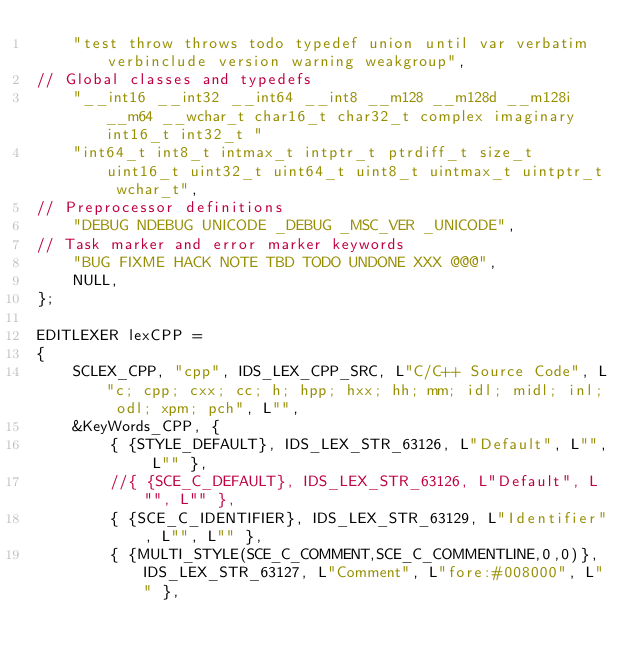<code> <loc_0><loc_0><loc_500><loc_500><_C_>    "test throw throws todo typedef union until var verbatim verbinclude version warning weakgroup",
// Global classes and typedefs
    "__int16 __int32 __int64 __int8 __m128 __m128d __m128i __m64 __wchar_t char16_t char32_t complex imaginary int16_t int32_t "
    "int64_t int8_t intmax_t intptr_t ptrdiff_t size_t uint16_t uint32_t uint64_t uint8_t uintmax_t uintptr_t wchar_t",
// Preprocessor definitions
    "DEBUG NDEBUG UNICODE _DEBUG _MSC_VER _UNICODE",
// Task marker and error marker keywords
    "BUG FIXME HACK NOTE TBD TODO UNDONE XXX @@@",
    NULL,
};

EDITLEXER lexCPP =
{
    SCLEX_CPP, "cpp", IDS_LEX_CPP_SRC, L"C/C++ Source Code", L"c; cpp; cxx; cc; h; hpp; hxx; hh; mm; idl; midl; inl; odl; xpm; pch", L"",
    &KeyWords_CPP, {
        { {STYLE_DEFAULT}, IDS_LEX_STR_63126, L"Default", L"", L"" },
        //{ {SCE_C_DEFAULT}, IDS_LEX_STR_63126, L"Default", L"", L"" },
        { {SCE_C_IDENTIFIER}, IDS_LEX_STR_63129, L"Identifier", L"", L"" },
        { {MULTI_STYLE(SCE_C_COMMENT,SCE_C_COMMENTLINE,0,0)}, IDS_LEX_STR_63127, L"Comment", L"fore:#008000", L"" },</code> 